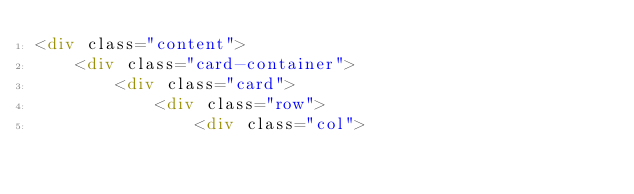<code> <loc_0><loc_0><loc_500><loc_500><_HTML_><div class="content">
    <div class="card-container">
        <div class="card">
            <div class="row">
                <div class="col"></code> 